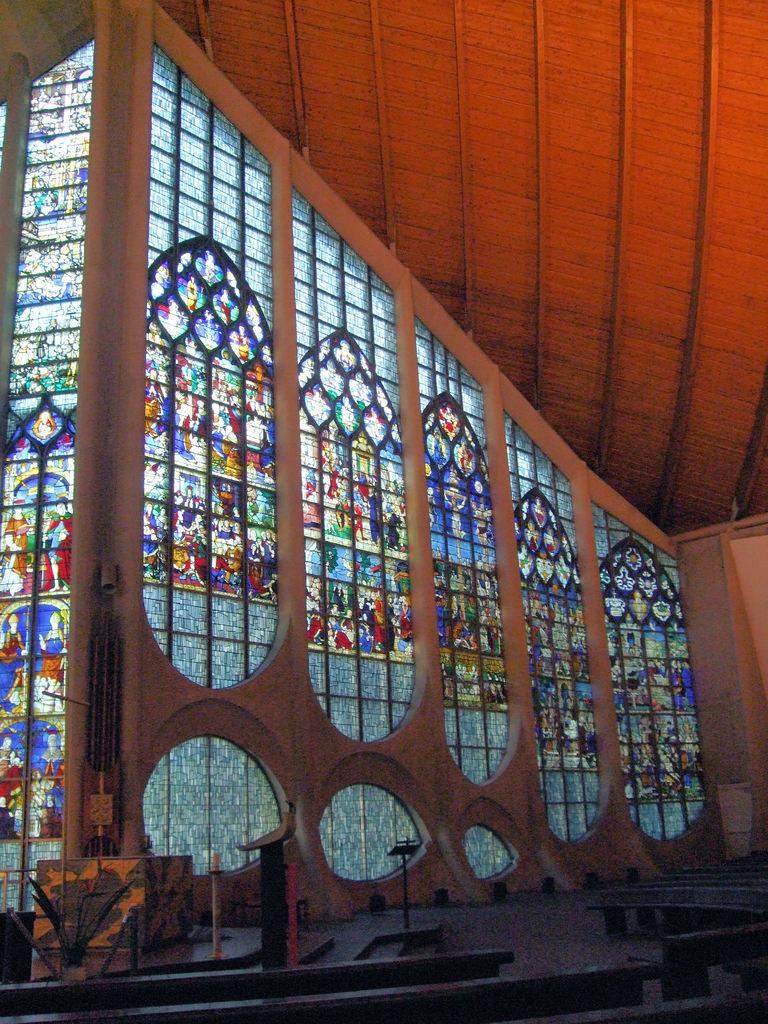What type of material is used for the windows in the image? The windows in the image are made of glass. What structure is present above the windows in the image? There is a roof in the image. What are the small vertical structures in the image? There are small poles in the image. What can be found on the floor in the image? There are objects on the floor in the image. What type of machine is used to grow the tomatoes in the image? There are no tomatoes or machines present in the image. What part of the body can be seen on the chin in the image? There is no chin or any part of the body present in the image. 